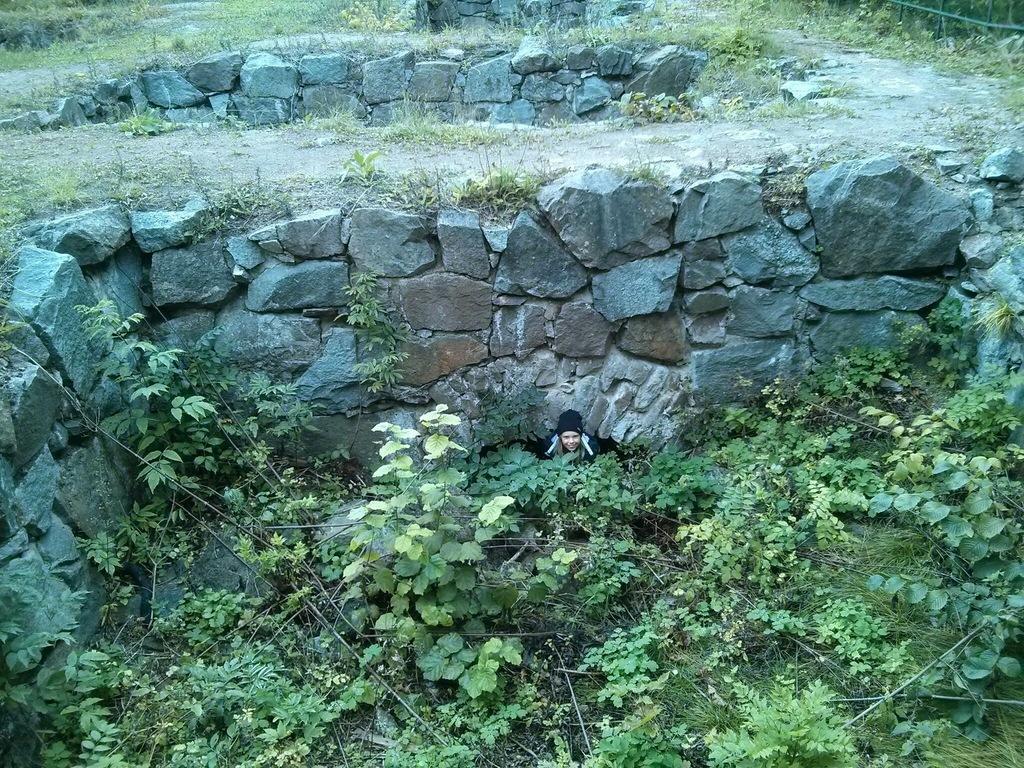Can you describe this image briefly? In this image we can see a person sitting in between trees, behind the person we can see a stone wall, there we can also see few plants, stones, trees. 